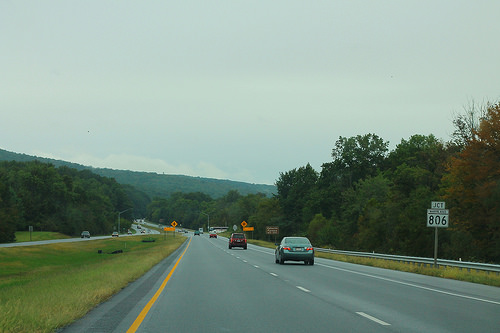<image>
Can you confirm if the sky is behind the forest? Yes. From this viewpoint, the sky is positioned behind the forest, with the forest partially or fully occluding the sky. Is the sign in front of the car? No. The sign is not in front of the car. The spatial positioning shows a different relationship between these objects. 